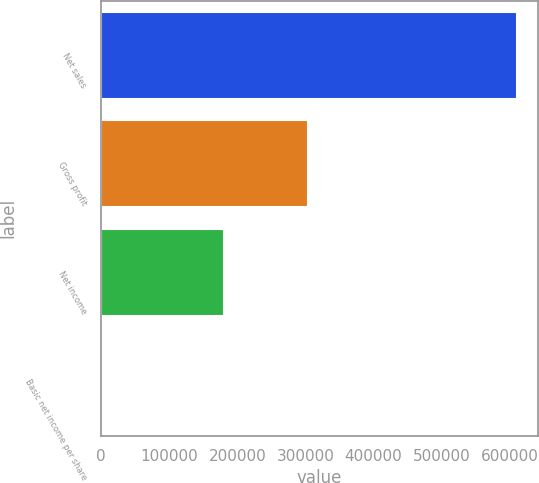<chart> <loc_0><loc_0><loc_500><loc_500><bar_chart><fcel>Net sales<fcel>Gross profit<fcel>Net income<fcel>Basic net income per share<nl><fcel>611224<fcel>304452<fcel>180343<fcel>0.84<nl></chart> 